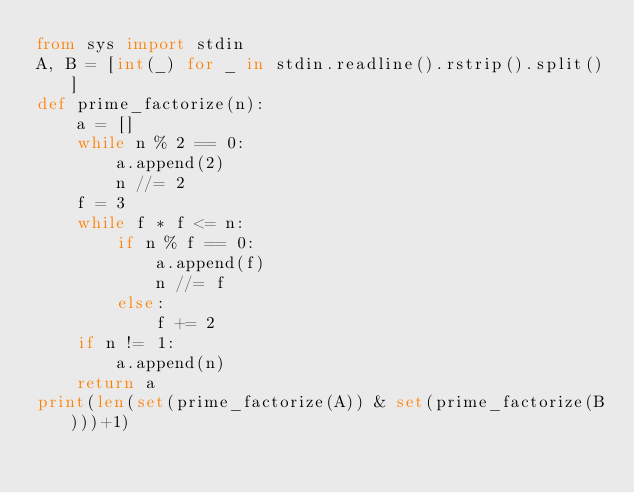Convert code to text. <code><loc_0><loc_0><loc_500><loc_500><_Python_>from sys import stdin
A, B = [int(_) for _ in stdin.readline().rstrip().split()]
def prime_factorize(n):
    a = []
    while n % 2 == 0:
        a.append(2)
        n //= 2
    f = 3
    while f * f <= n:
        if n % f == 0:
            a.append(f)
            n //= f
        else:
            f += 2
    if n != 1:
        a.append(n)
    return a
print(len(set(prime_factorize(A)) & set(prime_factorize(B)))+1)</code> 